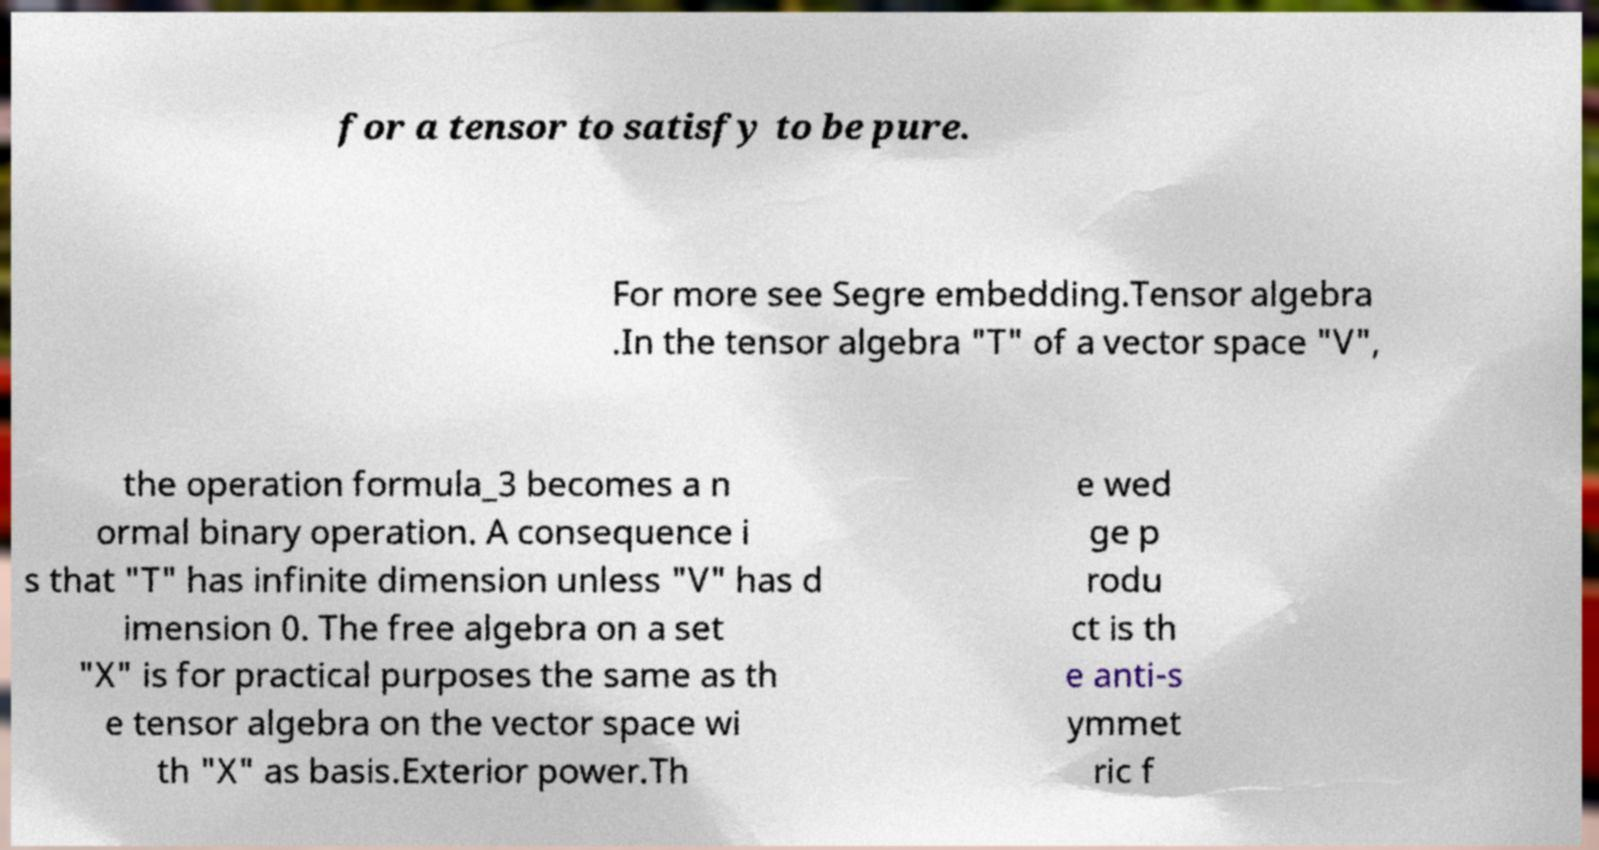There's text embedded in this image that I need extracted. Can you transcribe it verbatim? for a tensor to satisfy to be pure. For more see Segre embedding.Tensor algebra .In the tensor algebra "T" of a vector space "V", the operation formula_3 becomes a n ormal binary operation. A consequence i s that "T" has infinite dimension unless "V" has d imension 0. The free algebra on a set "X" is for practical purposes the same as th e tensor algebra on the vector space wi th "X" as basis.Exterior power.Th e wed ge p rodu ct is th e anti-s ymmet ric f 